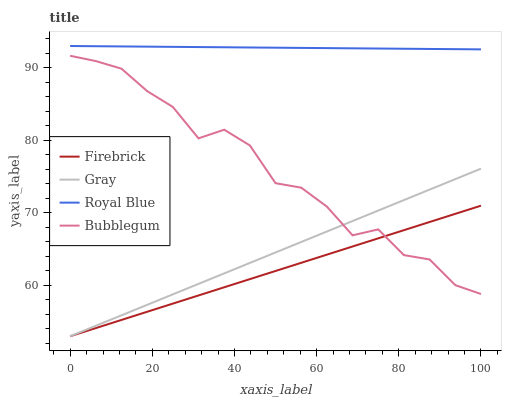Does Firebrick have the minimum area under the curve?
Answer yes or no. Yes. Does Royal Blue have the maximum area under the curve?
Answer yes or no. Yes. Does Bubblegum have the minimum area under the curve?
Answer yes or no. No. Does Bubblegum have the maximum area under the curve?
Answer yes or no. No. Is Firebrick the smoothest?
Answer yes or no. Yes. Is Bubblegum the roughest?
Answer yes or no. Yes. Is Bubblegum the smoothest?
Answer yes or no. No. Is Firebrick the roughest?
Answer yes or no. No. Does Gray have the lowest value?
Answer yes or no. Yes. Does Bubblegum have the lowest value?
Answer yes or no. No. Does Royal Blue have the highest value?
Answer yes or no. Yes. Does Bubblegum have the highest value?
Answer yes or no. No. Is Gray less than Royal Blue?
Answer yes or no. Yes. Is Royal Blue greater than Firebrick?
Answer yes or no. Yes. Does Bubblegum intersect Gray?
Answer yes or no. Yes. Is Bubblegum less than Gray?
Answer yes or no. No. Is Bubblegum greater than Gray?
Answer yes or no. No. Does Gray intersect Royal Blue?
Answer yes or no. No. 